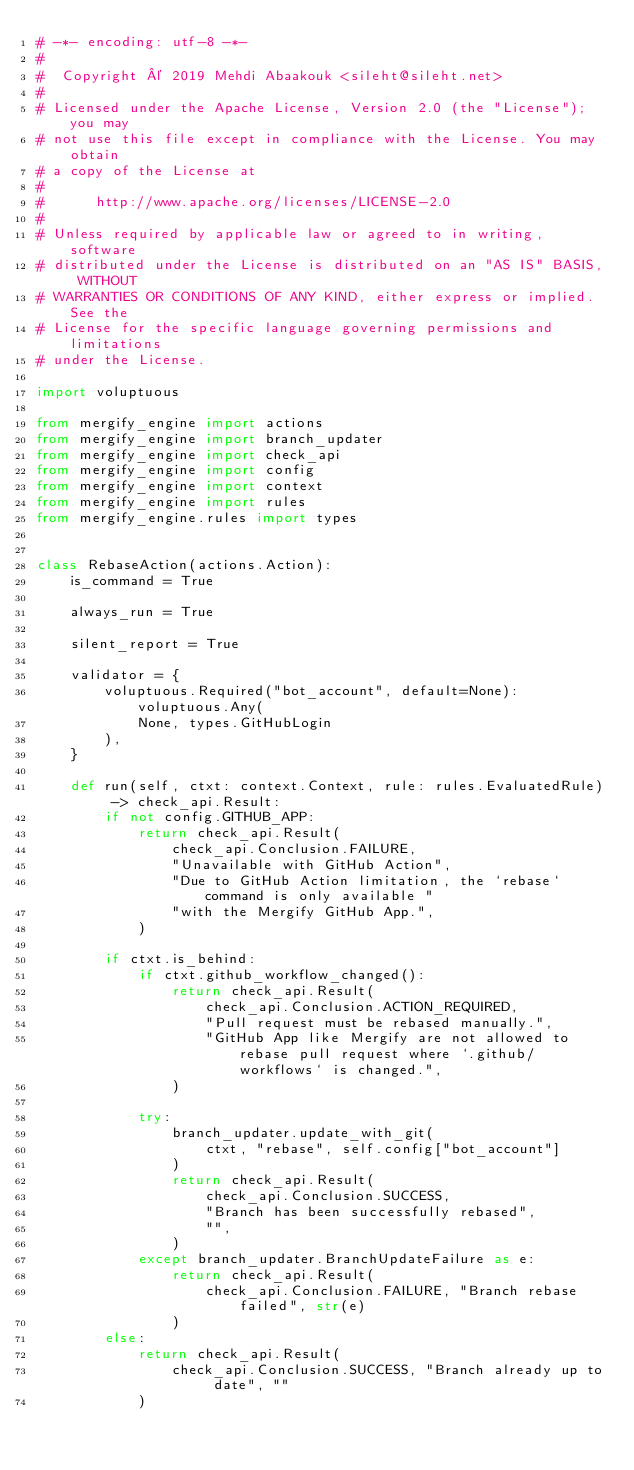<code> <loc_0><loc_0><loc_500><loc_500><_Python_># -*- encoding: utf-8 -*-
#
#  Copyright © 2019 Mehdi Abaakouk <sileht@sileht.net>
#
# Licensed under the Apache License, Version 2.0 (the "License"); you may
# not use this file except in compliance with the License. You may obtain
# a copy of the License at
#
#      http://www.apache.org/licenses/LICENSE-2.0
#
# Unless required by applicable law or agreed to in writing, software
# distributed under the License is distributed on an "AS IS" BASIS, WITHOUT
# WARRANTIES OR CONDITIONS OF ANY KIND, either express or implied. See the
# License for the specific language governing permissions and limitations
# under the License.

import voluptuous

from mergify_engine import actions
from mergify_engine import branch_updater
from mergify_engine import check_api
from mergify_engine import config
from mergify_engine import context
from mergify_engine import rules
from mergify_engine.rules import types


class RebaseAction(actions.Action):
    is_command = True

    always_run = True

    silent_report = True

    validator = {
        voluptuous.Required("bot_account", default=None): voluptuous.Any(
            None, types.GitHubLogin
        ),
    }

    def run(self, ctxt: context.Context, rule: rules.EvaluatedRule) -> check_api.Result:
        if not config.GITHUB_APP:
            return check_api.Result(
                check_api.Conclusion.FAILURE,
                "Unavailable with GitHub Action",
                "Due to GitHub Action limitation, the `rebase` command is only available "
                "with the Mergify GitHub App.",
            )

        if ctxt.is_behind:
            if ctxt.github_workflow_changed():
                return check_api.Result(
                    check_api.Conclusion.ACTION_REQUIRED,
                    "Pull request must be rebased manually.",
                    "GitHub App like Mergify are not allowed to rebase pull request where `.github/workflows` is changed.",
                )

            try:
                branch_updater.update_with_git(
                    ctxt, "rebase", self.config["bot_account"]
                )
                return check_api.Result(
                    check_api.Conclusion.SUCCESS,
                    "Branch has been successfully rebased",
                    "",
                )
            except branch_updater.BranchUpdateFailure as e:
                return check_api.Result(
                    check_api.Conclusion.FAILURE, "Branch rebase failed", str(e)
                )
        else:
            return check_api.Result(
                check_api.Conclusion.SUCCESS, "Branch already up to date", ""
            )
</code> 